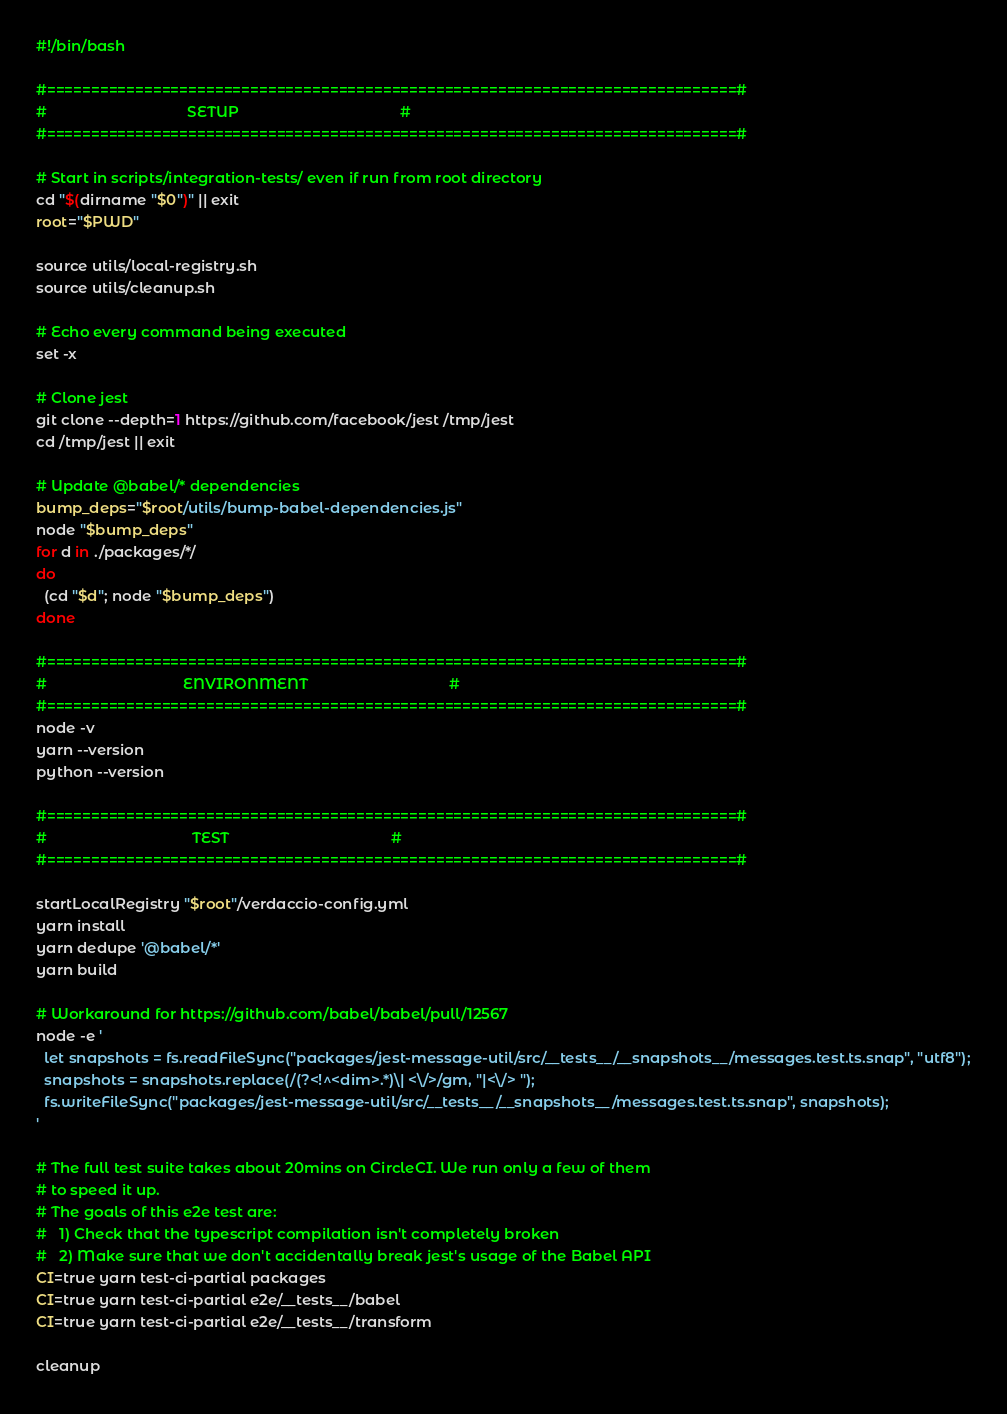<code> <loc_0><loc_0><loc_500><loc_500><_Bash_>#!/bin/bash

#==============================================================================#
#                                  SETUP                                       #
#==============================================================================#

# Start in scripts/integration-tests/ even if run from root directory
cd "$(dirname "$0")" || exit
root="$PWD"

source utils/local-registry.sh
source utils/cleanup.sh

# Echo every command being executed
set -x

# Clone jest
git clone --depth=1 https://github.com/facebook/jest /tmp/jest
cd /tmp/jest || exit

# Update @babel/* dependencies
bump_deps="$root/utils/bump-babel-dependencies.js"
node "$bump_deps"
for d in ./packages/*/
do
  (cd "$d"; node "$bump_deps")
done

#==============================================================================#
#                                 ENVIRONMENT                                  #
#==============================================================================#
node -v
yarn --version
python --version

#==============================================================================#
#                                   TEST                                       #
#==============================================================================#

startLocalRegistry "$root"/verdaccio-config.yml
yarn install
yarn dedupe '@babel/*'
yarn build

# Workaround for https://github.com/babel/babel/pull/12567
node -e '
  let snapshots = fs.readFileSync("packages/jest-message-util/src/__tests__/__snapshots__/messages.test.ts.snap", "utf8");
  snapshots = snapshots.replace(/(?<!^<dim>.*)\| <\/>/gm, "|<\/> ");
  fs.writeFileSync("packages/jest-message-util/src/__tests__/__snapshots__/messages.test.ts.snap", snapshots);
'

# The full test suite takes about 20mins on CircleCI. We run only a few of them
# to speed it up.
# The goals of this e2e test are:
#   1) Check that the typescript compilation isn't completely broken
#   2) Make sure that we don't accidentally break jest's usage of the Babel API
CI=true yarn test-ci-partial packages
CI=true yarn test-ci-partial e2e/__tests__/babel
CI=true yarn test-ci-partial e2e/__tests__/transform

cleanup
</code> 